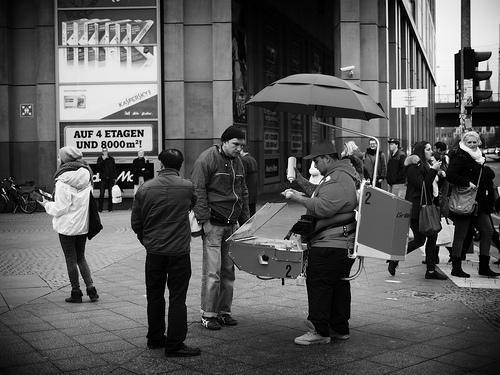How many umbrellas are in this picture?
Give a very brief answer. 1. How many people are holding a condiment dispenser?
Give a very brief answer. 1. 